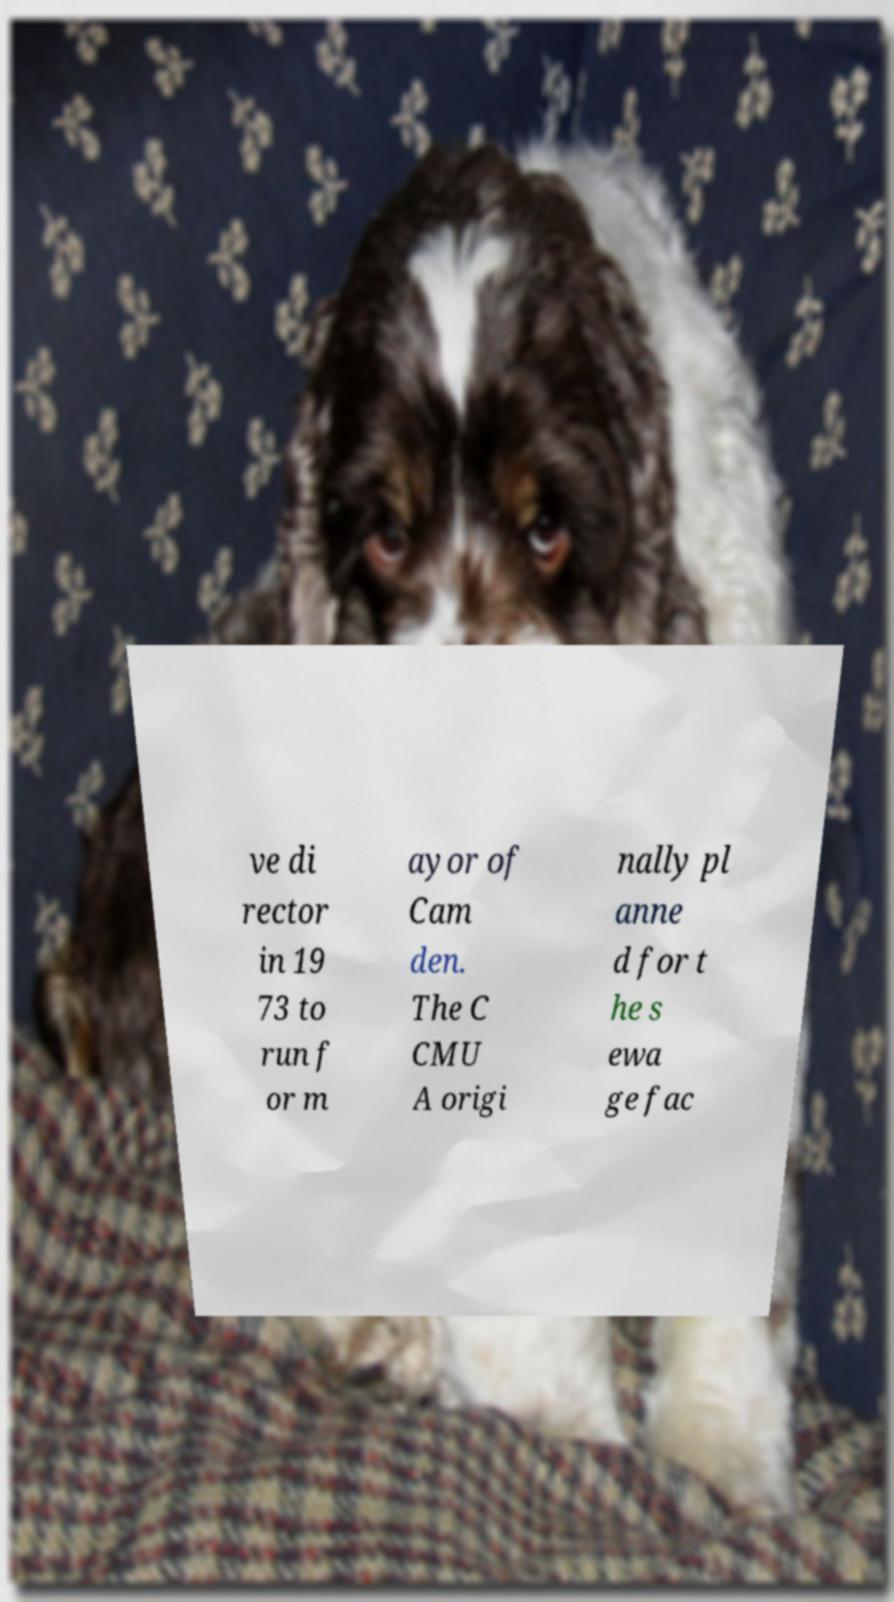What messages or text are displayed in this image? I need them in a readable, typed format. ve di rector in 19 73 to run f or m ayor of Cam den. The C CMU A origi nally pl anne d for t he s ewa ge fac 